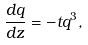Convert formula to latex. <formula><loc_0><loc_0><loc_500><loc_500>\frac { d q } { d z } = - t q ^ { 3 } ,</formula> 